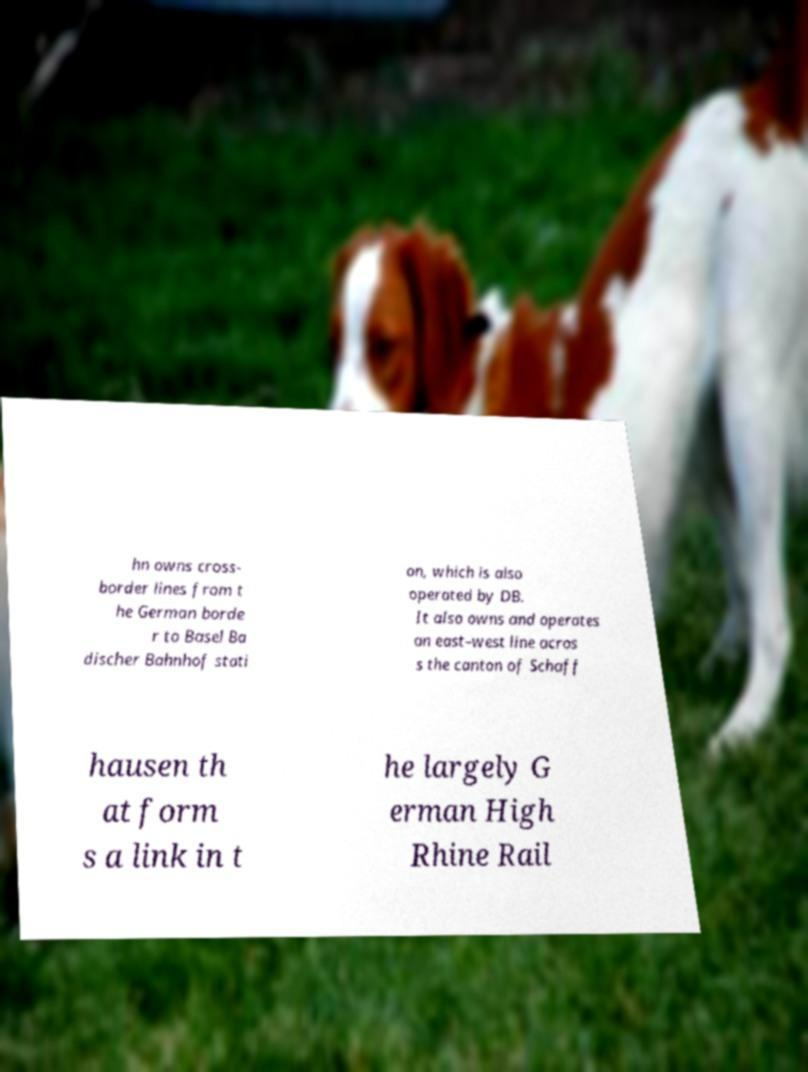There's text embedded in this image that I need extracted. Can you transcribe it verbatim? hn owns cross- border lines from t he German borde r to Basel Ba discher Bahnhof stati on, which is also operated by DB. It also owns and operates an east–west line acros s the canton of Schaff hausen th at form s a link in t he largely G erman High Rhine Rail 